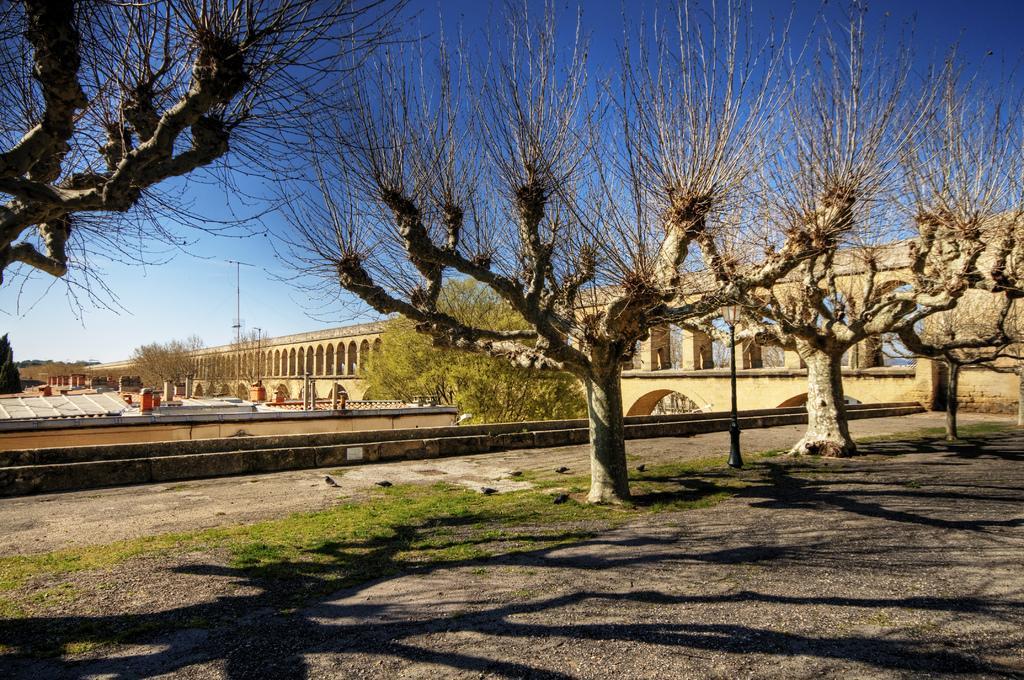In one or two sentences, can you explain what this image depicts? This picture is clicked outside the city. In front of the picture, we see trees. There are buildings, trees and electric poles in the background. On the right side, we see a building or a bridge in yellow color. At the top of the picture, we see the sky, which is blue in color. 